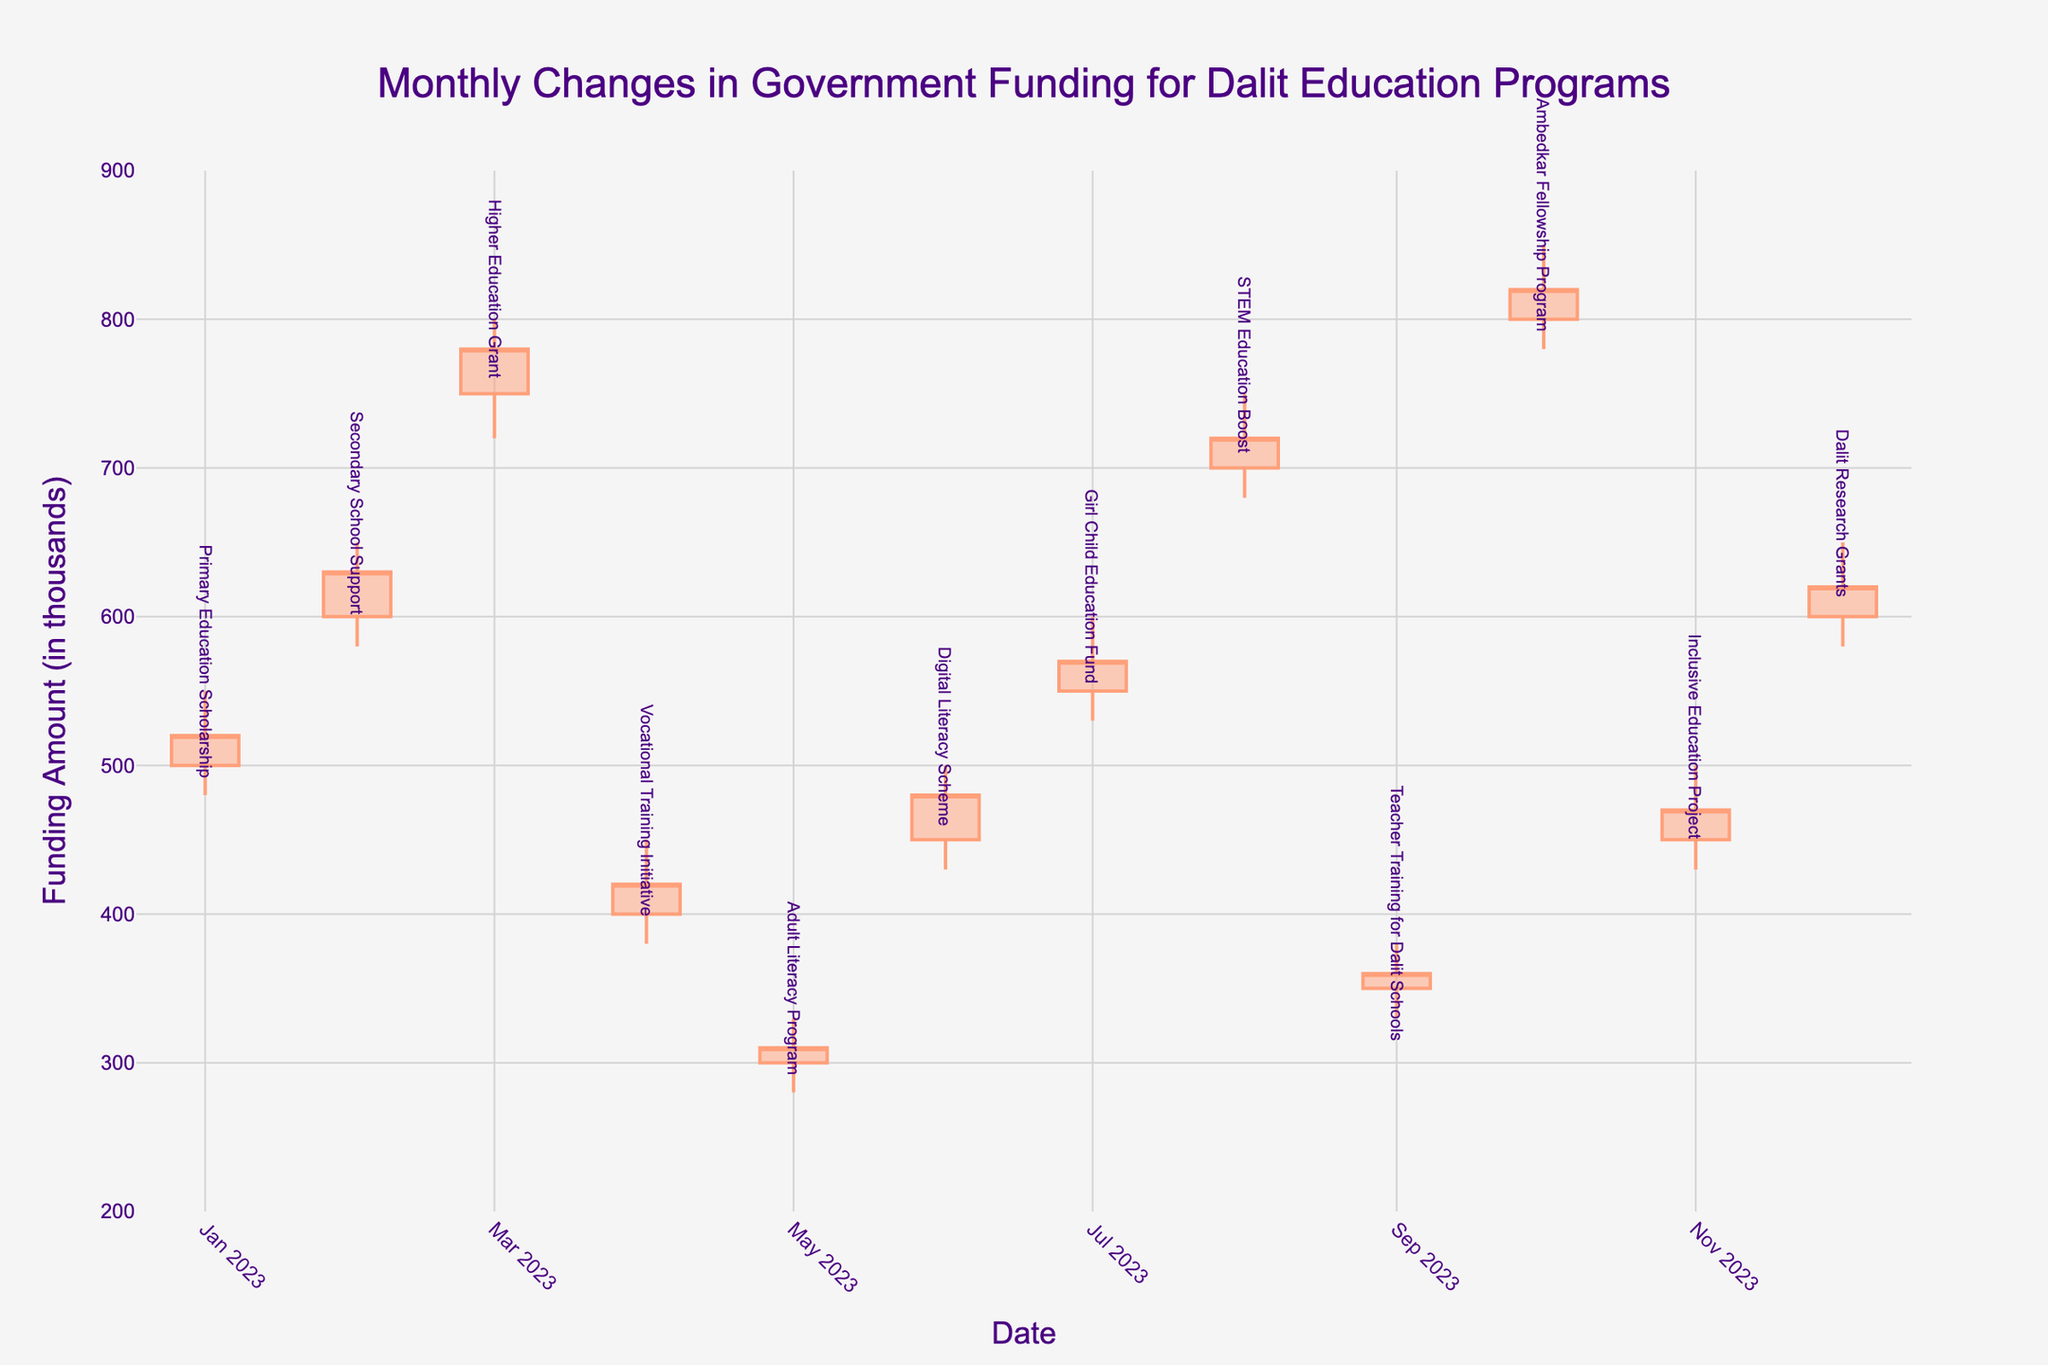What is the title of the figure? The title is prominently displayed at the top of the figure.
Answer: Monthly Changes in Government Funding for Dalit Education Programs Which program has the highest funding allocation for December 2023? Look for the candlestick corresponding to December 2023. The highest value is represented by the top of the upper shadow.
Answer: Dalit Research Grants What is the funding range for the Primary Education Scholarship in January 2023? For January 2023, find the candlestick for the Primary Education Scholarship. The range is given by the low and high values.
Answer: 480 to 550 Which month shows the highest closing funding amount in the chart? Identify the month with the highest closing value by looking at the top of the body of each candlestick.
Answer: October 2023 In which month did the Digital Literacy Scheme have its highest funding allocation? Find the month where the candlestick for the Digital Literacy Scheme has the highest value, indicated by the top of the upper shadow.
Answer: June 2023 What is the difference between the closing funding amounts for the Higher Education Grant in March 2023 and the Ambedkar Fellowship Program in October 2023? Find the closing amounts for both programs in the respective months and compute the difference: 820 - 780.
Answer: 40 How many months experienced a decrease in funding allocation compared to the previous month's closing amount? Count the candlesticks where the closing price is lower than the previous month's closing price, indicated by the color of the candlestick.
Answer: 4 Which education program received the least amount of funding in 2023? Identify the candlestick with the lowest value, represented by the bottom of the lower shadow.
Answer: Adult Literacy Program (May 2023) Between which two consecutive months did the STEM Education Boost see the highest increase in funding? Compare the differences between consecutive monthly closing amounts for the STEM Education Boost and find the maximum increase.
Answer: July and August 2023 How does the funding trend for the Inclusive Education Project in November 2023 compare to that for the Digital Literacy Scheme in June 2023? Compare the opening, closing, high, and low values for these two months and note the differences in trends, such as whether they increased or decreased.
Answer: Both saw an increase, but Digital Literacy Scheme had a higher high 